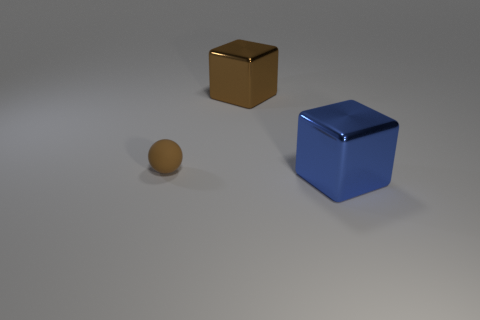Add 3 blue cubes. How many objects exist? 6 Subtract all blocks. How many objects are left? 1 Subtract all large blue shiny objects. Subtract all big blue metal cubes. How many objects are left? 1 Add 1 large brown metal objects. How many large brown metal objects are left? 2 Add 2 tiny rubber objects. How many tiny rubber objects exist? 3 Subtract 0 cyan balls. How many objects are left? 3 